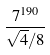Convert formula to latex. <formula><loc_0><loc_0><loc_500><loc_500>\frac { 7 ^ { 1 9 0 } } { \sqrt { 4 } / 8 }</formula> 